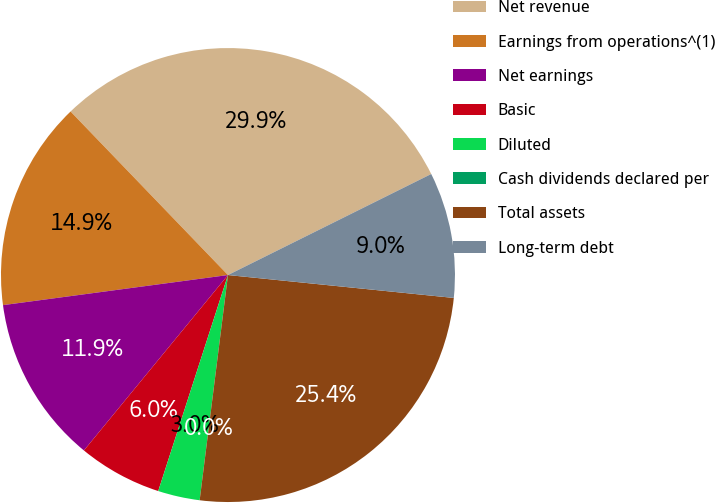<chart> <loc_0><loc_0><loc_500><loc_500><pie_chart><fcel>Net revenue<fcel>Earnings from operations^(1)<fcel>Net earnings<fcel>Basic<fcel>Diluted<fcel>Cash dividends declared per<fcel>Total assets<fcel>Long-term debt<nl><fcel>29.85%<fcel>14.92%<fcel>11.94%<fcel>5.97%<fcel>2.98%<fcel>0.0%<fcel>25.38%<fcel>8.95%<nl></chart> 